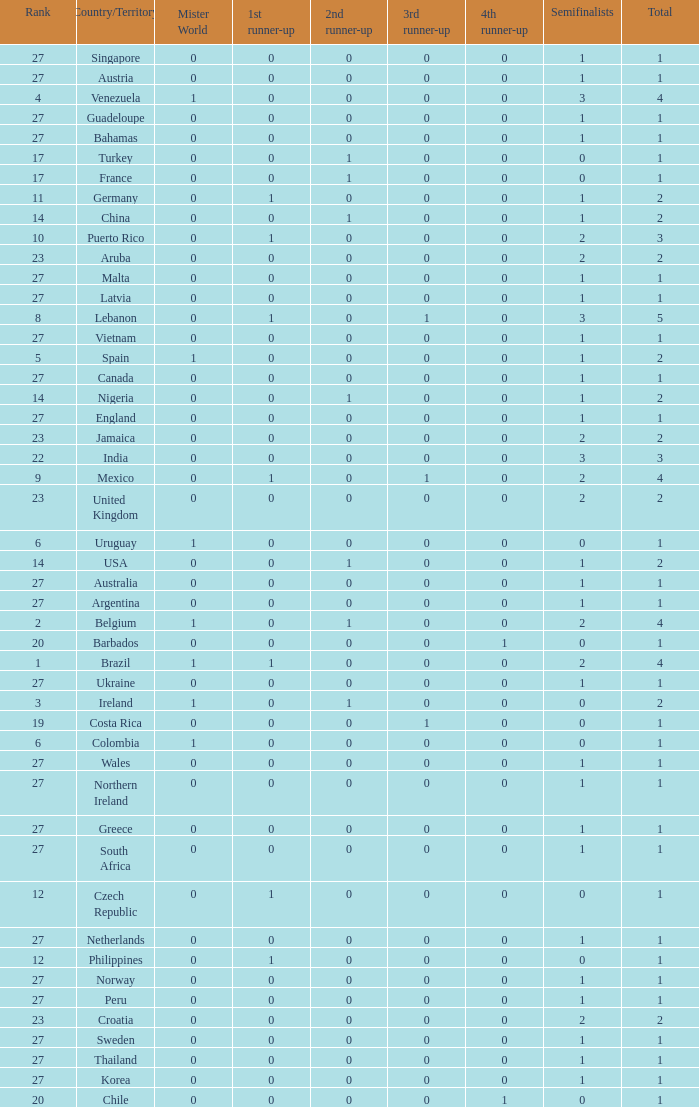How many 3rd runner up values does Turkey have? 1.0. 